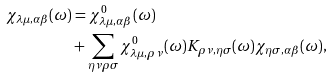<formula> <loc_0><loc_0><loc_500><loc_500>\chi _ { \lambda \mu , \alpha \beta } ( \omega ) & = \chi ^ { 0 } _ { \lambda \mu , \alpha \beta } ( \omega ) \\ & + \sum _ { \eta \nu \rho \sigma } \chi ^ { 0 } _ { \lambda \mu , \rho \nu } ( \omega ) K _ { \rho \nu , \eta \sigma } ( \omega ) \chi _ { \eta \sigma , \alpha \beta } ( \omega ) ,</formula> 